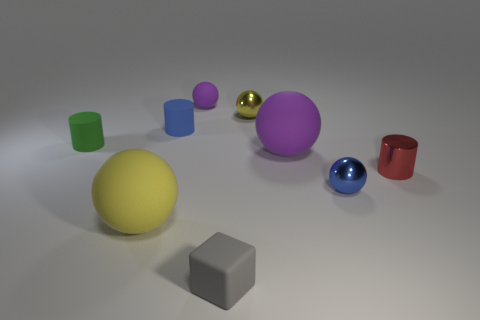Subtract all blue balls. How many balls are left? 4 Subtract all blue balls. How many balls are left? 4 Subtract 1 spheres. How many spheres are left? 4 Subtract all red spheres. Subtract all yellow cylinders. How many spheres are left? 5 Add 1 small gray things. How many objects exist? 10 Subtract all cylinders. How many objects are left? 6 Add 9 small blue metal balls. How many small blue metal balls exist? 10 Subtract 0 cyan balls. How many objects are left? 9 Subtract all big yellow spheres. Subtract all small gray blocks. How many objects are left? 7 Add 8 yellow rubber things. How many yellow rubber things are left? 9 